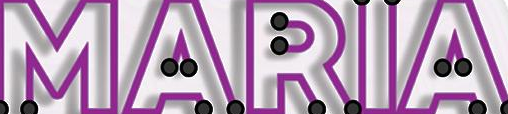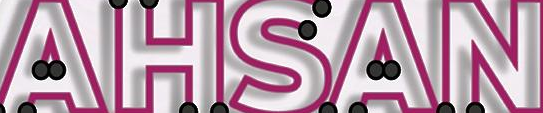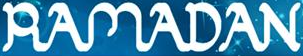Read the text from these images in sequence, separated by a semicolon. MARIA; AHSAN; RAMADAN 